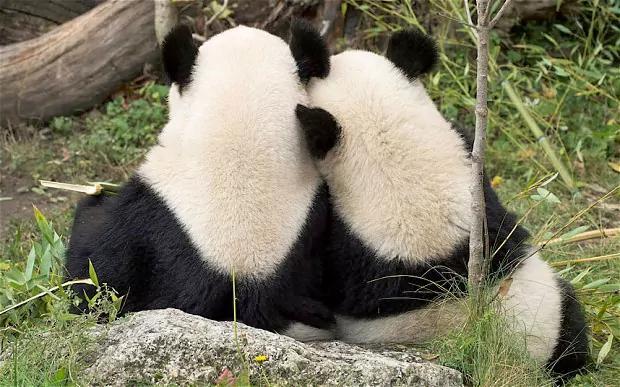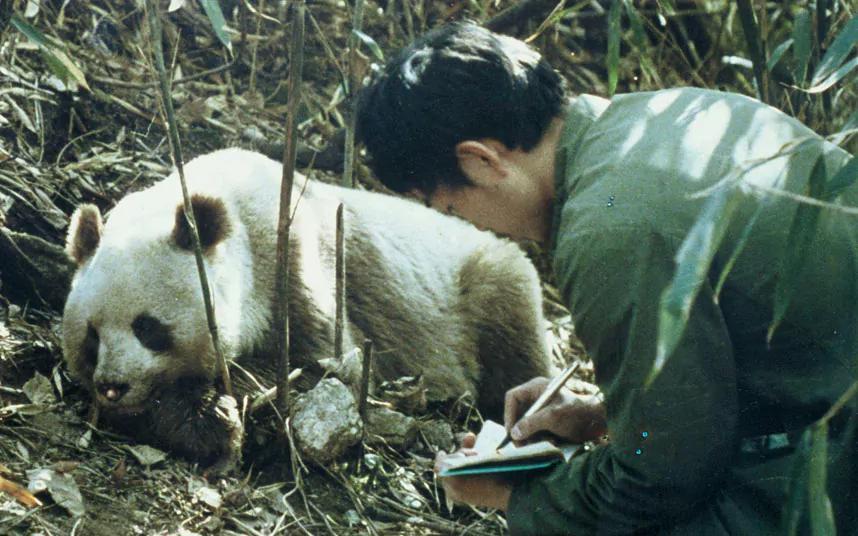The first image is the image on the left, the second image is the image on the right. Given the left and right images, does the statement "In one image, a standing panda figure on the right is looking down toward another panda, and in the other image, the mouth of a panda with its body turned leftward and its face forward is next to leafy foliage." hold true? Answer yes or no. No. The first image is the image on the left, the second image is the image on the right. Evaluate the accuracy of this statement regarding the images: "There are two different animal species in the right image.". Is it true? Answer yes or no. Yes. 